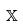Convert formula to latex. <formula><loc_0><loc_0><loc_500><loc_500>\mathbb { X }</formula> 